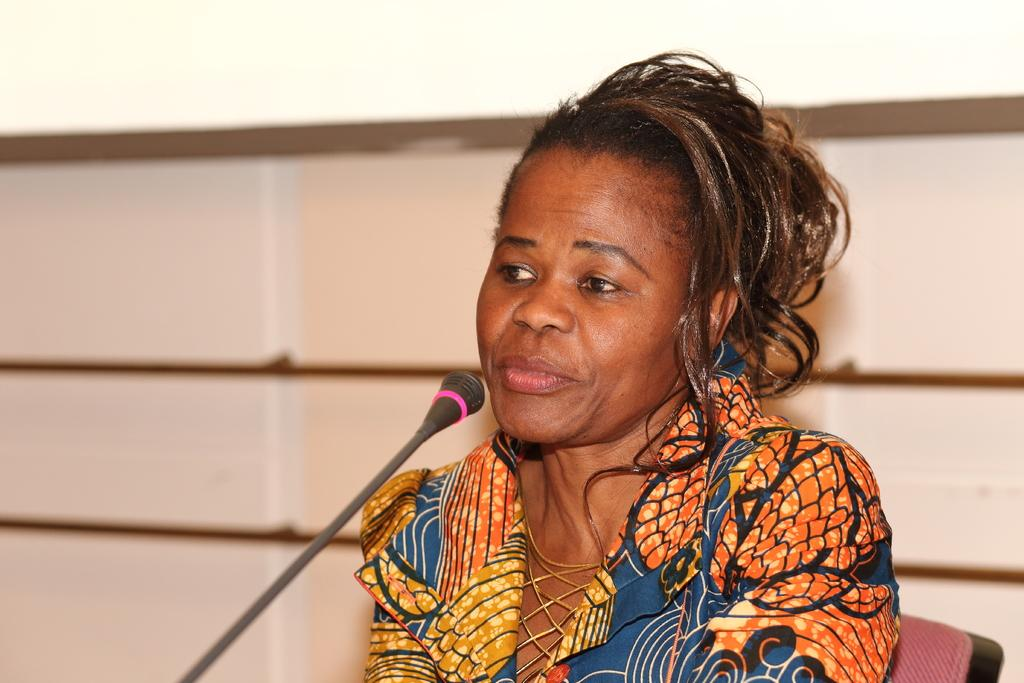What object is located at the front of the image? There is a microphone in the front of the image. What is the woman in the image doing? The woman is sitting on a chair in the center of the image. What can be seen behind the woman? There is a wall in the background of the image. What type of curve or arch can be seen in the image? There is no curve or arch present in the image. Does the existence of the microphone in the image prove the existence of sound waves? The presence of a microphone in the image does not prove the existence of sound waves, as it only indicates that someone might be recording or amplifying sound. 